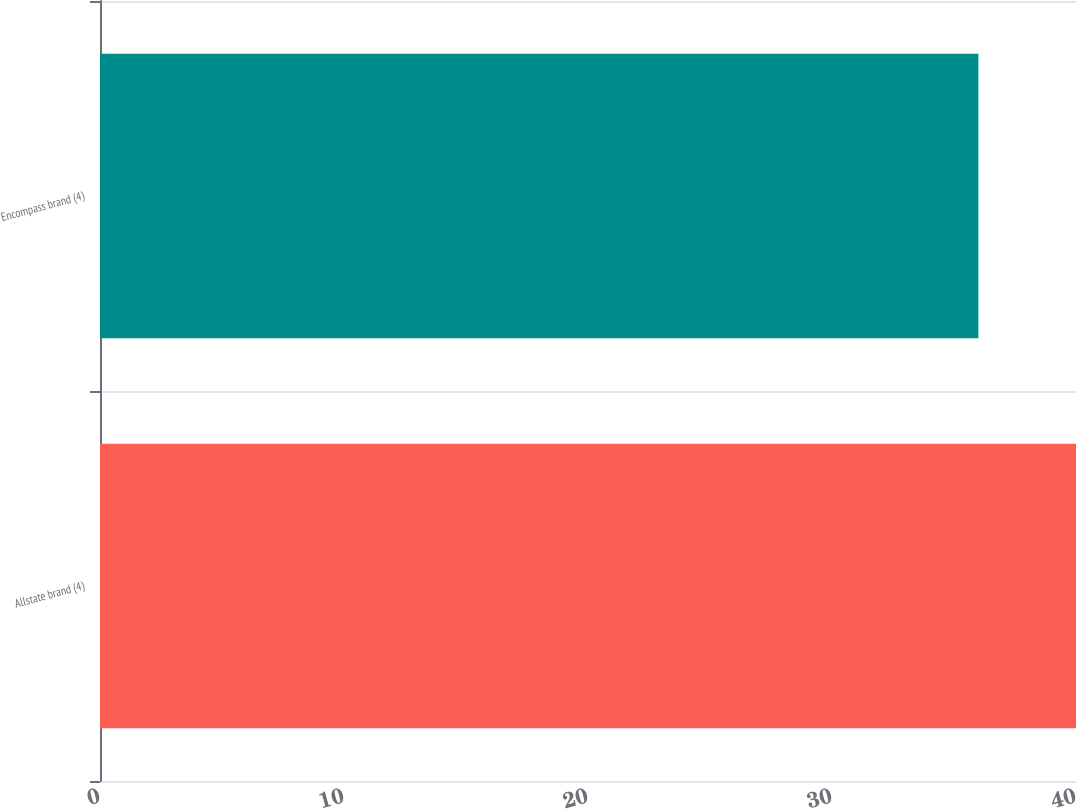<chart> <loc_0><loc_0><loc_500><loc_500><bar_chart><fcel>Allstate brand (4)<fcel>Encompass brand (4)<nl><fcel>40<fcel>36<nl></chart> 